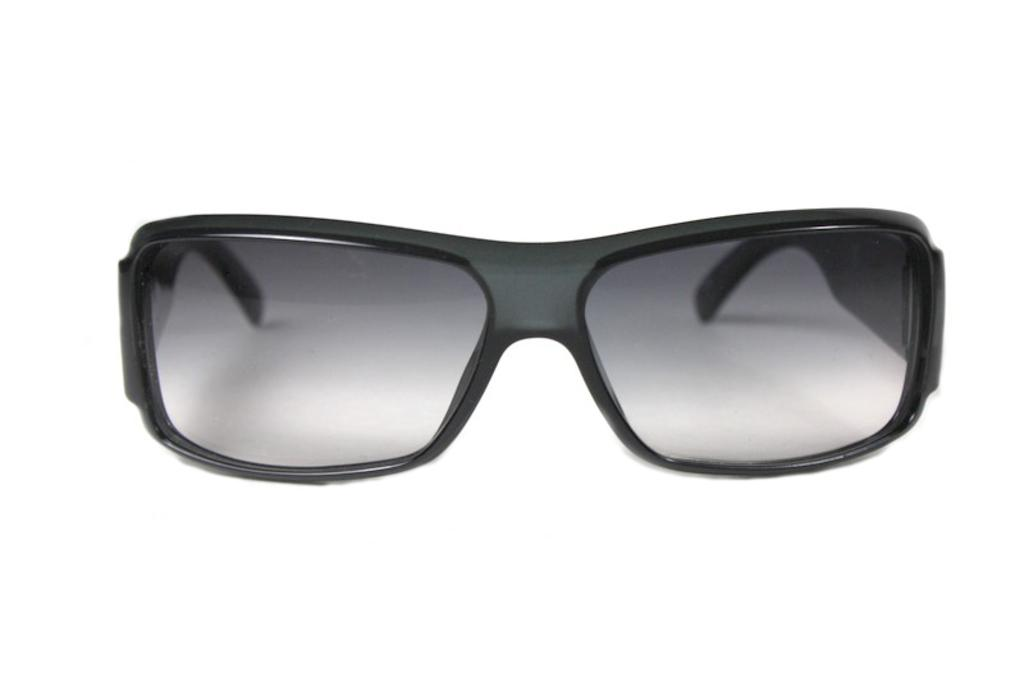What type of accessory is present in the image? There are goggles in the image. What color are the goggles? The goggles are black in color. What is the color of the background in the image? The background of the image is white in color. How many crows can be seen in the image? There are no crows present in the image. 